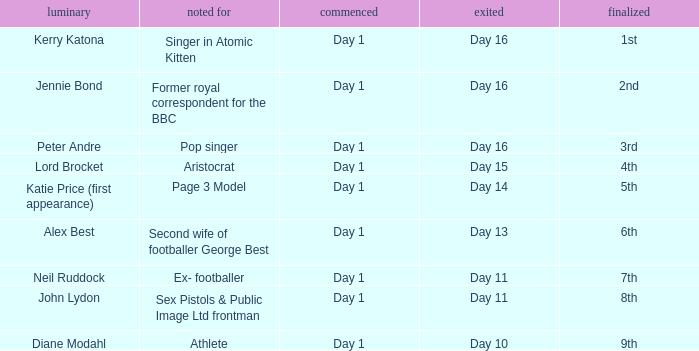Name the number of celebrity for athlete 1.0. 